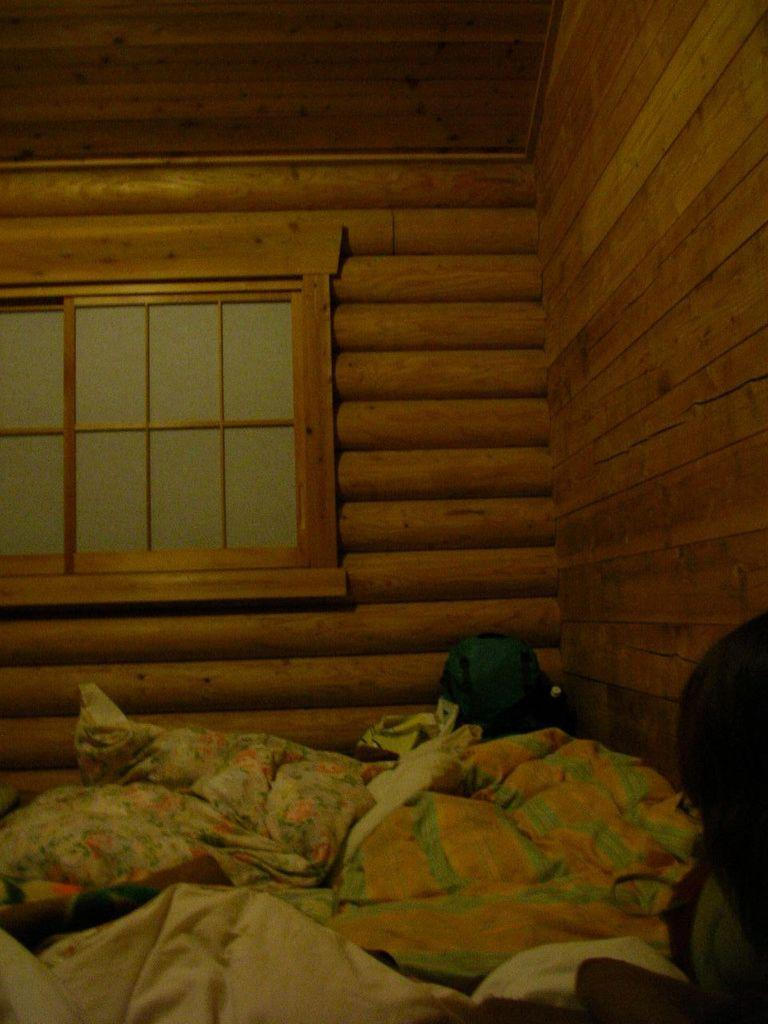What type of soft furnishings can be seen in the image? There are pillows and blankets in the image. What material is the wall in the background made of? The wall in the background of the image is made of wood. What type of snake is hiding under the pillows in the image? There is no snake present in the image; it only features pillows, blankets, and a wooden wall. 